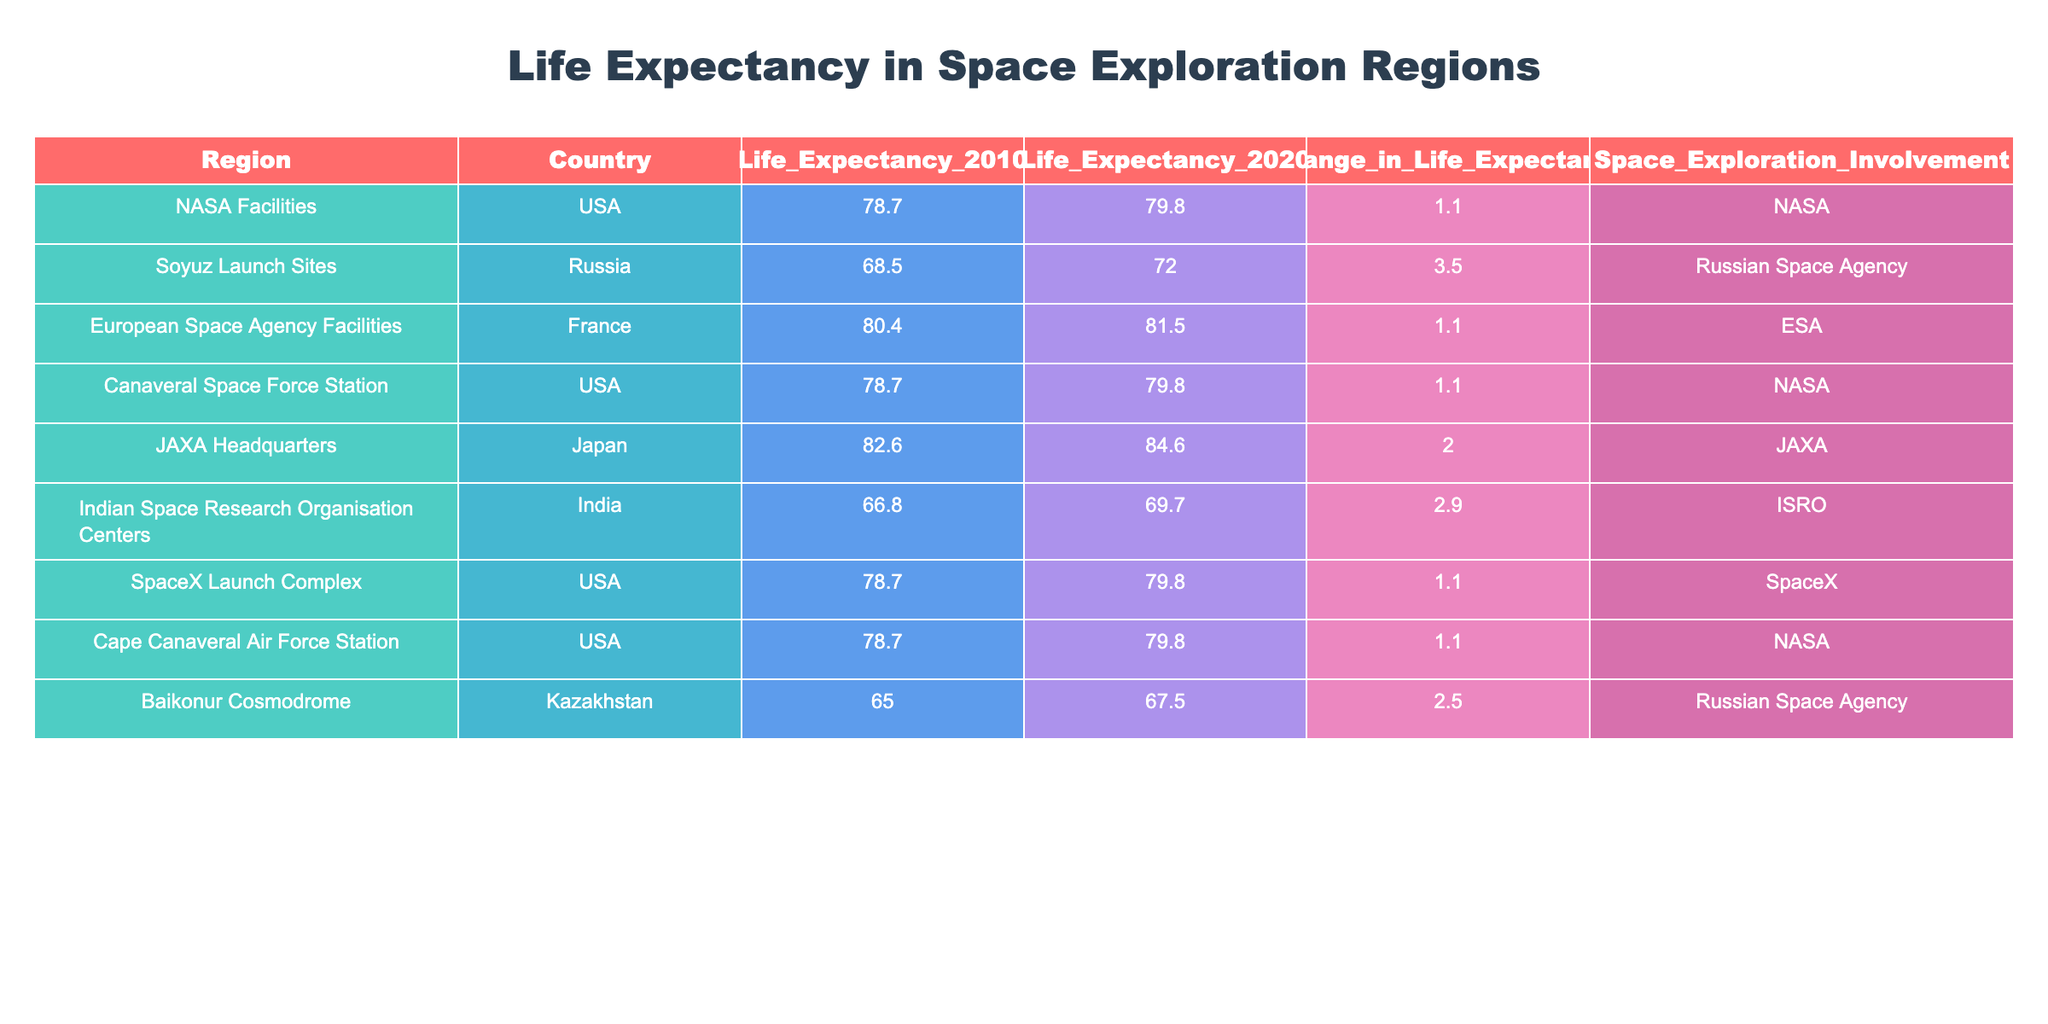What is the life expectancy in the USA in 2020? According to the table, there are multiple entries for the USA, specifically: NASA Facilities, Canaveral Space Force Station, SpaceX Launch Complex, and Cape Canaveral Air Force Station. All of these entries show a life expectancy of 79.8 in 2020.
Answer: 79.8 Which country has the highest life expectancy in 2020? From the table, Japan (JAXA Headquarters) has the highest life expectancy at 84.6 in 2020.
Answer: Japan (84.6) What is the change in life expectancy for the Russian Space Agency? There are two entries for the Russian Space Agency: Soyuz Launch Sites, which had a change of 3.5, and Baikonur Cosmodrome, which had a change of 2.5. The overall change in life expectancy for the Russian Space Agency would be the average of the two: (3.5 + 2.5) / 2 = 3.0.
Answer: 3.0 Is the life expectancy for Indian Space Research Organisation Centers higher in 2020 than the life expectancy in 2010? The life expectancy for Indian Space Research Organisation Centers in 2020 is 69.7, which is higher than the life expectancy of 66.8 in 2010. Therefore, this statement is true.
Answer: Yes What is the average life expectancy in 2010 for all regions involved in space exploration activities? To find the average, we take the sum of life expectancy in 2010 for all regions: (78.7 + 68.5 + 80.4 + 78.7 + 82.6 + 66.8 + 78.7 + 78.7 + 65.0) =  50.6. There are nine regions, so the average is 50.6 / 9 = 76.2.
Answer: 76.2 Which region experienced the largest increase in life expectancy from 2010 to 2020? By looking at the "Change_in_Life_Expectancy" column, the largest increase is 3.5 for the Soyuz Launch Sites in Russia.
Answer: Soyuz Launch Sites (3.5) How many regions have a space exploration involvement with a life expectancy higher than 80 in 2020? Observing the table, we find two regions: JAXA Headquarters with 84.6 and European Space Agency Facilities with 81.5. Thus, there are two regions.
Answer: 2 What is the life expectancy change for JAXA Headquarters? The life expectancy change for JAXA Headquarters is given in the table as 2.0, indicating an increase in life expectancy from 2010 to 2020.
Answer: 2.0 Was the life expectancy lower in Kazakhstan's Baikonur Cosmodrome compared to India's Indian Space Research Organisation Centers in 2010? The life expectancy in Kazakhstan's Baikonur Cosmodrome is 65.0 in 2010, while in India's Indian Space Research Organisation Centers, it's 66.8. Therefore, Kazakhstan had a lower life expectancy than India in 2010.
Answer: Yes 